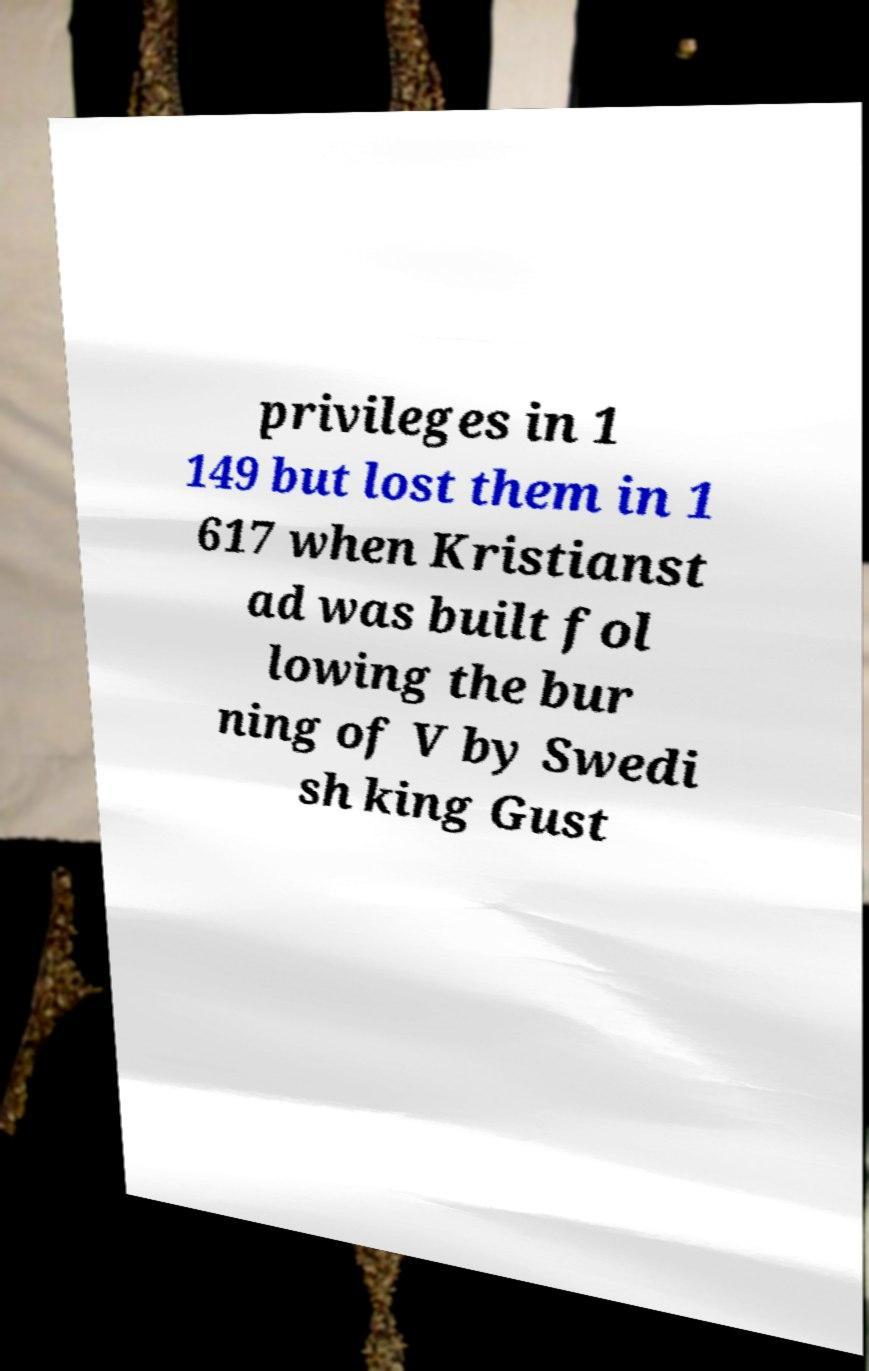There's text embedded in this image that I need extracted. Can you transcribe it verbatim? privileges in 1 149 but lost them in 1 617 when Kristianst ad was built fol lowing the bur ning of V by Swedi sh king Gust 